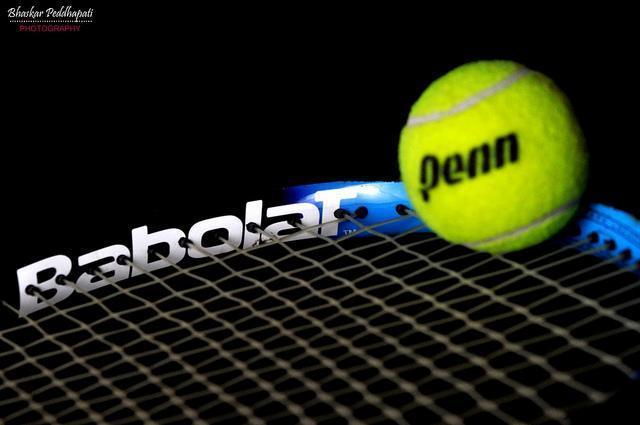How many tennis rackets are there?
Give a very brief answer. 1. 